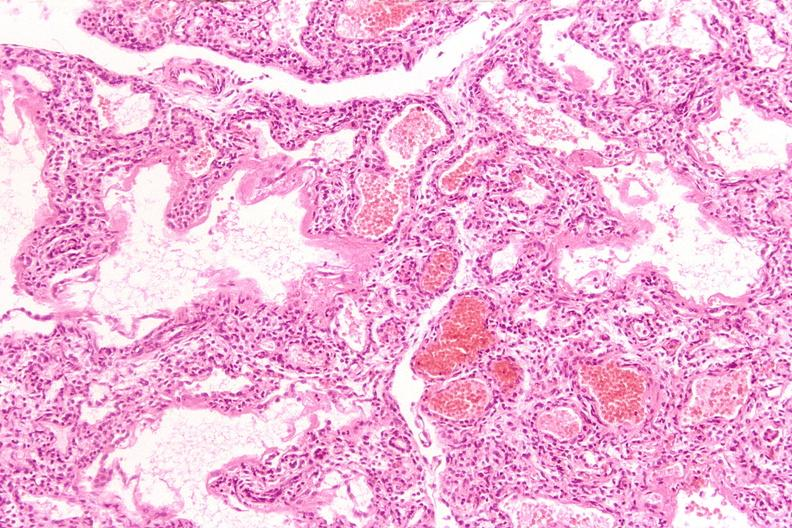does this image show lungs, hyaline membrane disease?
Answer the question using a single word or phrase. Yes 